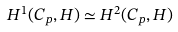<formula> <loc_0><loc_0><loc_500><loc_500>H ^ { 1 } ( C _ { p } , H ) \simeq H ^ { 2 } ( C _ { p } , H )</formula> 